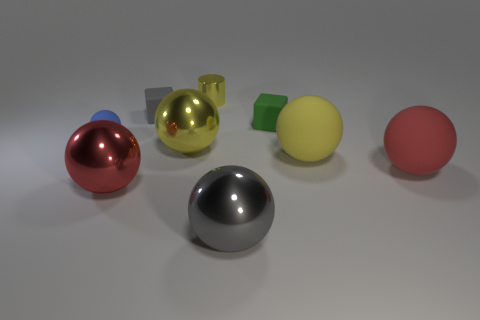Subtract all big gray balls. How many balls are left? 5 Subtract all yellow cylinders. How many yellow balls are left? 2 Subtract 1 balls. How many balls are left? 5 Subtract all gray spheres. How many spheres are left? 5 Add 1 large red balls. How many objects exist? 10 Subtract all balls. How many objects are left? 3 Subtract all red spheres. Subtract all yellow cubes. How many spheres are left? 4 Subtract all tiny metal cylinders. Subtract all small rubber things. How many objects are left? 5 Add 1 small yellow shiny cylinders. How many small yellow shiny cylinders are left? 2 Add 1 big gray metal spheres. How many big gray metal spheres exist? 2 